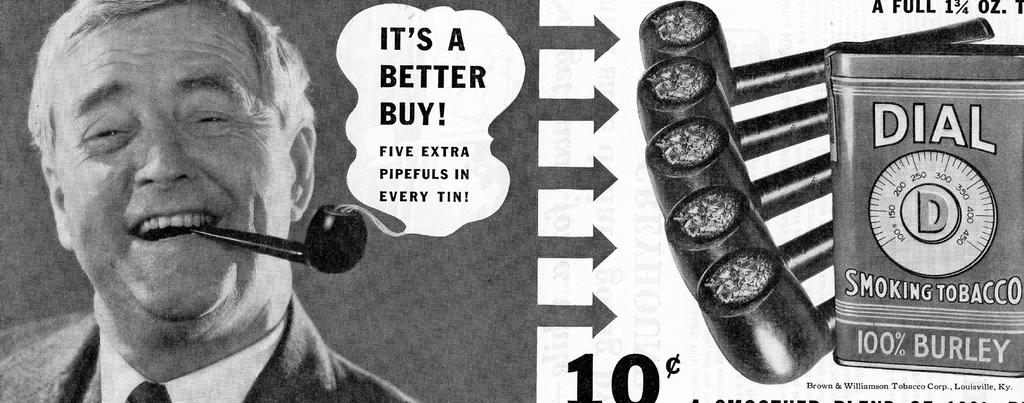What is the person in the image holding? The person is holding a cigar pipe in the image. How many cigar pipes are visible in the image? There are multiple cigar pipes in the image. What else can be seen in the image besides the cigar pipes? There are other objects in the image. Is there any text written on the image? Yes, there is text written on the image. What is the color scheme of the image? The image is in black and white. How much does the bag weigh in the image? There is no bag present in the image, so it is not possible to determine its weight. 